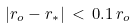<formula> <loc_0><loc_0><loc_500><loc_500>| r _ { o } - r _ { * } | \, < \, 0 . 1 \, r _ { o }</formula> 